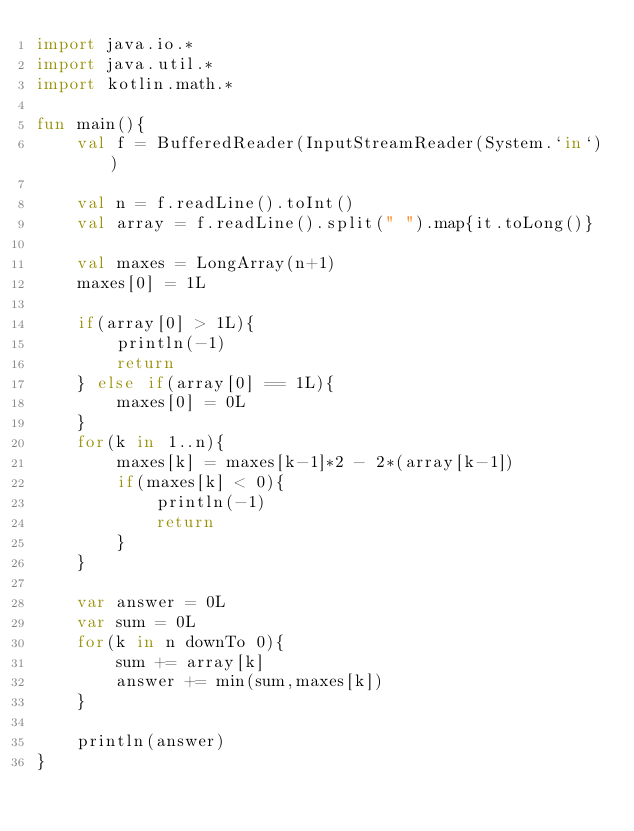Convert code to text. <code><loc_0><loc_0><loc_500><loc_500><_Kotlin_>import java.io.*
import java.util.*
import kotlin.math.*

fun main(){
	val f = BufferedReader(InputStreamReader(System.`in`))

	val n = f.readLine().toInt()
	val array = f.readLine().split(" ").map{it.toLong()}

	val maxes = LongArray(n+1)
	maxes[0] = 1L

	if(array[0] > 1L){
		println(-1)
		return
	} else if(array[0] == 1L){
		maxes[0] = 0L
	}
	for(k in 1..n){
		maxes[k] = maxes[k-1]*2 - 2*(array[k-1])
		if(maxes[k] < 0){
			println(-1)
			return
		}
	}

	var answer = 0L
	var sum = 0L
	for(k in n downTo 0){
		sum += array[k]
		answer += min(sum,maxes[k])
	}

	println(answer)
}
</code> 